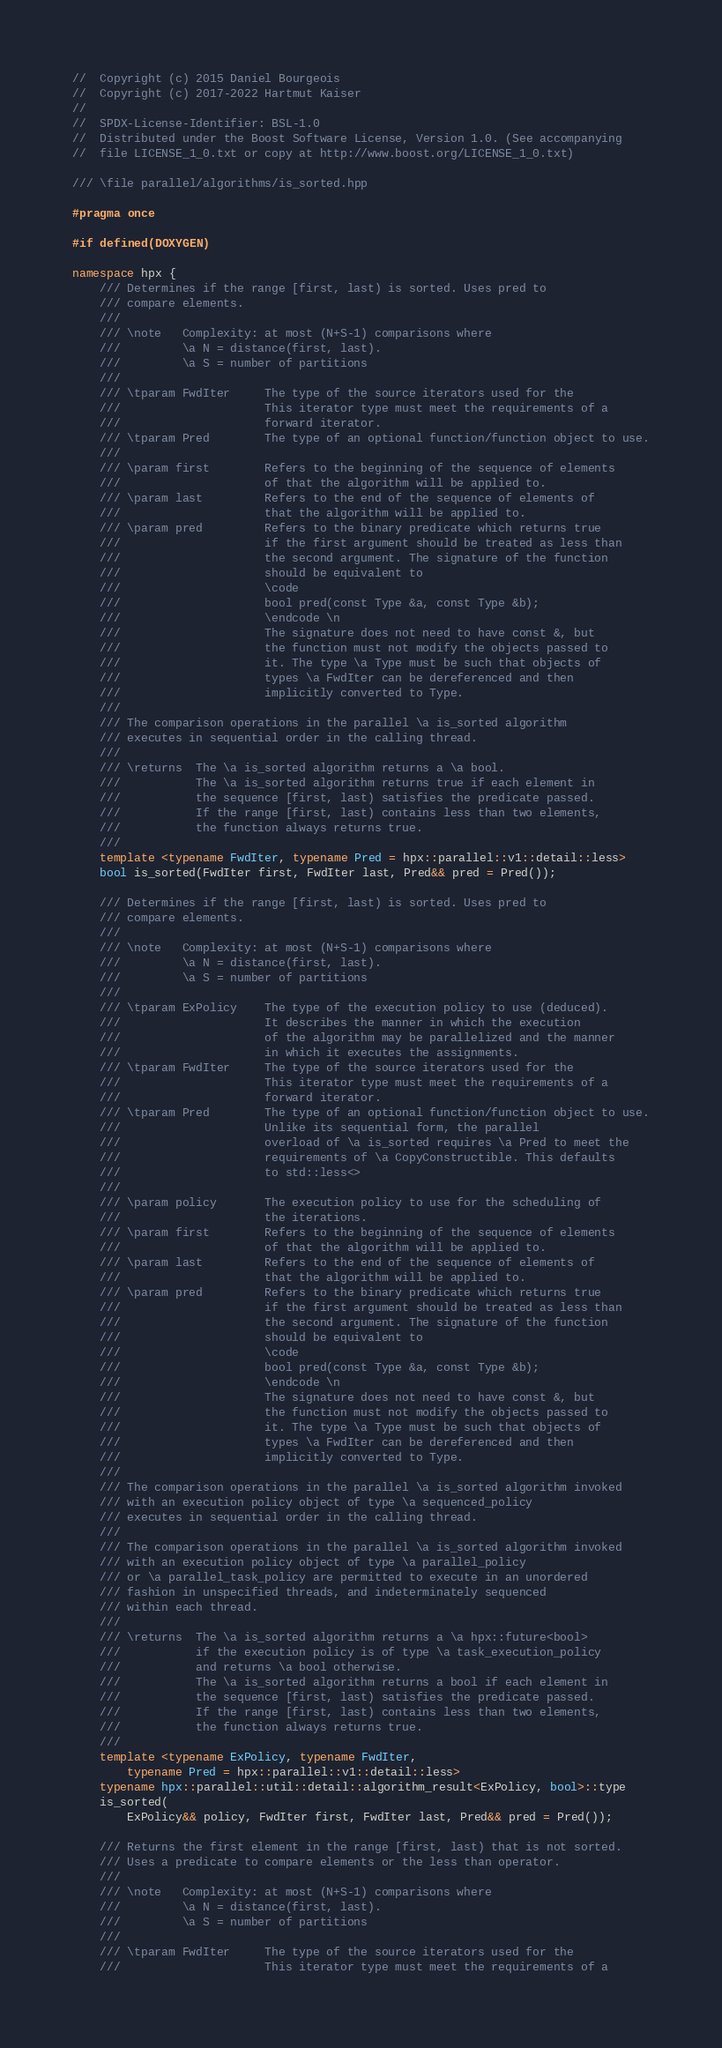Convert code to text. <code><loc_0><loc_0><loc_500><loc_500><_C++_>//  Copyright (c) 2015 Daniel Bourgeois
//  Copyright (c) 2017-2022 Hartmut Kaiser
//
//  SPDX-License-Identifier: BSL-1.0
//  Distributed under the Boost Software License, Version 1.0. (See accompanying
//  file LICENSE_1_0.txt or copy at http://www.boost.org/LICENSE_1_0.txt)

/// \file parallel/algorithms/is_sorted.hpp

#pragma once

#if defined(DOXYGEN)

namespace hpx {
    /// Determines if the range [first, last) is sorted. Uses pred to
    /// compare elements.
    ///
    /// \note   Complexity: at most (N+S-1) comparisons where
    ///         \a N = distance(first, last).
    ///         \a S = number of partitions
    ///
    /// \tparam FwdIter     The type of the source iterators used for the
    ///                     This iterator type must meet the requirements of a
    ///                     forward iterator.
    /// \tparam Pred        The type of an optional function/function object to use.
    ///
    /// \param first        Refers to the beginning of the sequence of elements
    ///                     of that the algorithm will be applied to.
    /// \param last         Refers to the end of the sequence of elements of
    ///                     that the algorithm will be applied to.
    /// \param pred         Refers to the binary predicate which returns true
    ///                     if the first argument should be treated as less than
    ///                     the second argument. The signature of the function
    ///                     should be equivalent to
    ///                     \code
    ///                     bool pred(const Type &a, const Type &b);
    ///                     \endcode \n
    ///                     The signature does not need to have const &, but
    ///                     the function must not modify the objects passed to
    ///                     it. The type \a Type must be such that objects of
    ///                     types \a FwdIter can be dereferenced and then
    ///                     implicitly converted to Type.
    ///
    /// The comparison operations in the parallel \a is_sorted algorithm
    /// executes in sequential order in the calling thread.
    ///
    /// \returns  The \a is_sorted algorithm returns a \a bool.
    ///           The \a is_sorted algorithm returns true if each element in
    ///           the sequence [first, last) satisfies the predicate passed.
    ///           If the range [first, last) contains less than two elements,
    ///           the function always returns true.
    ///
    template <typename FwdIter, typename Pred = hpx::parallel::v1::detail::less>
    bool is_sorted(FwdIter first, FwdIter last, Pred&& pred = Pred());

    /// Determines if the range [first, last) is sorted. Uses pred to
    /// compare elements.
    ///
    /// \note   Complexity: at most (N+S-1) comparisons where
    ///         \a N = distance(first, last).
    ///         \a S = number of partitions
    ///
    /// \tparam ExPolicy    The type of the execution policy to use (deduced).
    ///                     It describes the manner in which the execution
    ///                     of the algorithm may be parallelized and the manner
    ///                     in which it executes the assignments.
    /// \tparam FwdIter     The type of the source iterators used for the
    ///                     This iterator type must meet the requirements of a
    ///                     forward iterator.
    /// \tparam Pred        The type of an optional function/function object to use.
    ///                     Unlike its sequential form, the parallel
    ///                     overload of \a is_sorted requires \a Pred to meet the
    ///                     requirements of \a CopyConstructible. This defaults
    ///                     to std::less<>
    ///
    /// \param policy       The execution policy to use for the scheduling of
    ///                     the iterations.
    /// \param first        Refers to the beginning of the sequence of elements
    ///                     of that the algorithm will be applied to.
    /// \param last         Refers to the end of the sequence of elements of
    ///                     that the algorithm will be applied to.
    /// \param pred         Refers to the binary predicate which returns true
    ///                     if the first argument should be treated as less than
    ///                     the second argument. The signature of the function
    ///                     should be equivalent to
    ///                     \code
    ///                     bool pred(const Type &a, const Type &b);
    ///                     \endcode \n
    ///                     The signature does not need to have const &, but
    ///                     the function must not modify the objects passed to
    ///                     it. The type \a Type must be such that objects of
    ///                     types \a FwdIter can be dereferenced and then
    ///                     implicitly converted to Type.
    ///
    /// The comparison operations in the parallel \a is_sorted algorithm invoked
    /// with an execution policy object of type \a sequenced_policy
    /// executes in sequential order in the calling thread.
    ///
    /// The comparison operations in the parallel \a is_sorted algorithm invoked
    /// with an execution policy object of type \a parallel_policy
    /// or \a parallel_task_policy are permitted to execute in an unordered
    /// fashion in unspecified threads, and indeterminately sequenced
    /// within each thread.
    ///
    /// \returns  The \a is_sorted algorithm returns a \a hpx::future<bool>
    ///           if the execution policy is of type \a task_execution_policy
    ///           and returns \a bool otherwise.
    ///           The \a is_sorted algorithm returns a bool if each element in
    ///           the sequence [first, last) satisfies the predicate passed.
    ///           If the range [first, last) contains less than two elements,
    ///           the function always returns true.
    ///
    template <typename ExPolicy, typename FwdIter,
        typename Pred = hpx::parallel::v1::detail::less>
    typename hpx::parallel::util::detail::algorithm_result<ExPolicy, bool>::type
    is_sorted(
        ExPolicy&& policy, FwdIter first, FwdIter last, Pred&& pred = Pred());

    /// Returns the first element in the range [first, last) that is not sorted.
    /// Uses a predicate to compare elements or the less than operator.
    ///
    /// \note   Complexity: at most (N+S-1) comparisons where
    ///         \a N = distance(first, last).
    ///         \a S = number of partitions
    ///
    /// \tparam FwdIter     The type of the source iterators used for the
    ///                     This iterator type must meet the requirements of a</code> 